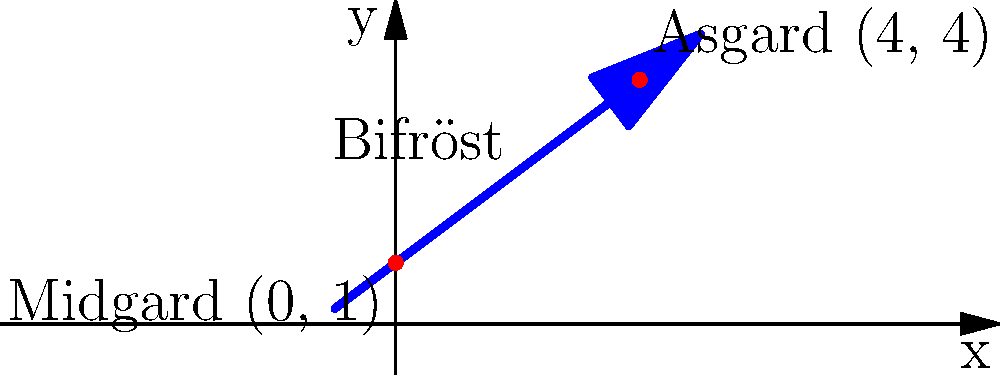In Norse mythology, the rainbow bridge Bifröst connects Midgard (Earth) to Asgard (realm of the gods). If we represent Midgard as the point (0, 1) and Asgard as (4, 4) on a coordinate plane, what is the slope of Bifröst? To find the slope of Bifröst, we can use the slope formula:

$$ m = \frac{y_2 - y_1}{x_2 - x_1} $$

Where $(x_1, y_1)$ represents Midgard and $(x_2, y_2)$ represents Asgard.

Step 1: Identify the coordinates
Midgard: $(x_1, y_1) = (0, 1)$
Asgard: $(x_2, y_2) = (4, 4)$

Step 2: Plug the values into the slope formula
$$ m = \frac{4 - 1}{4 - 0} $$

Step 3: Simplify
$$ m = \frac{3}{4} = 0.75 $$

Therefore, the slope of Bifröst is $\frac{3}{4}$ or 0.75.
Answer: $\frac{3}{4}$ or 0.75 